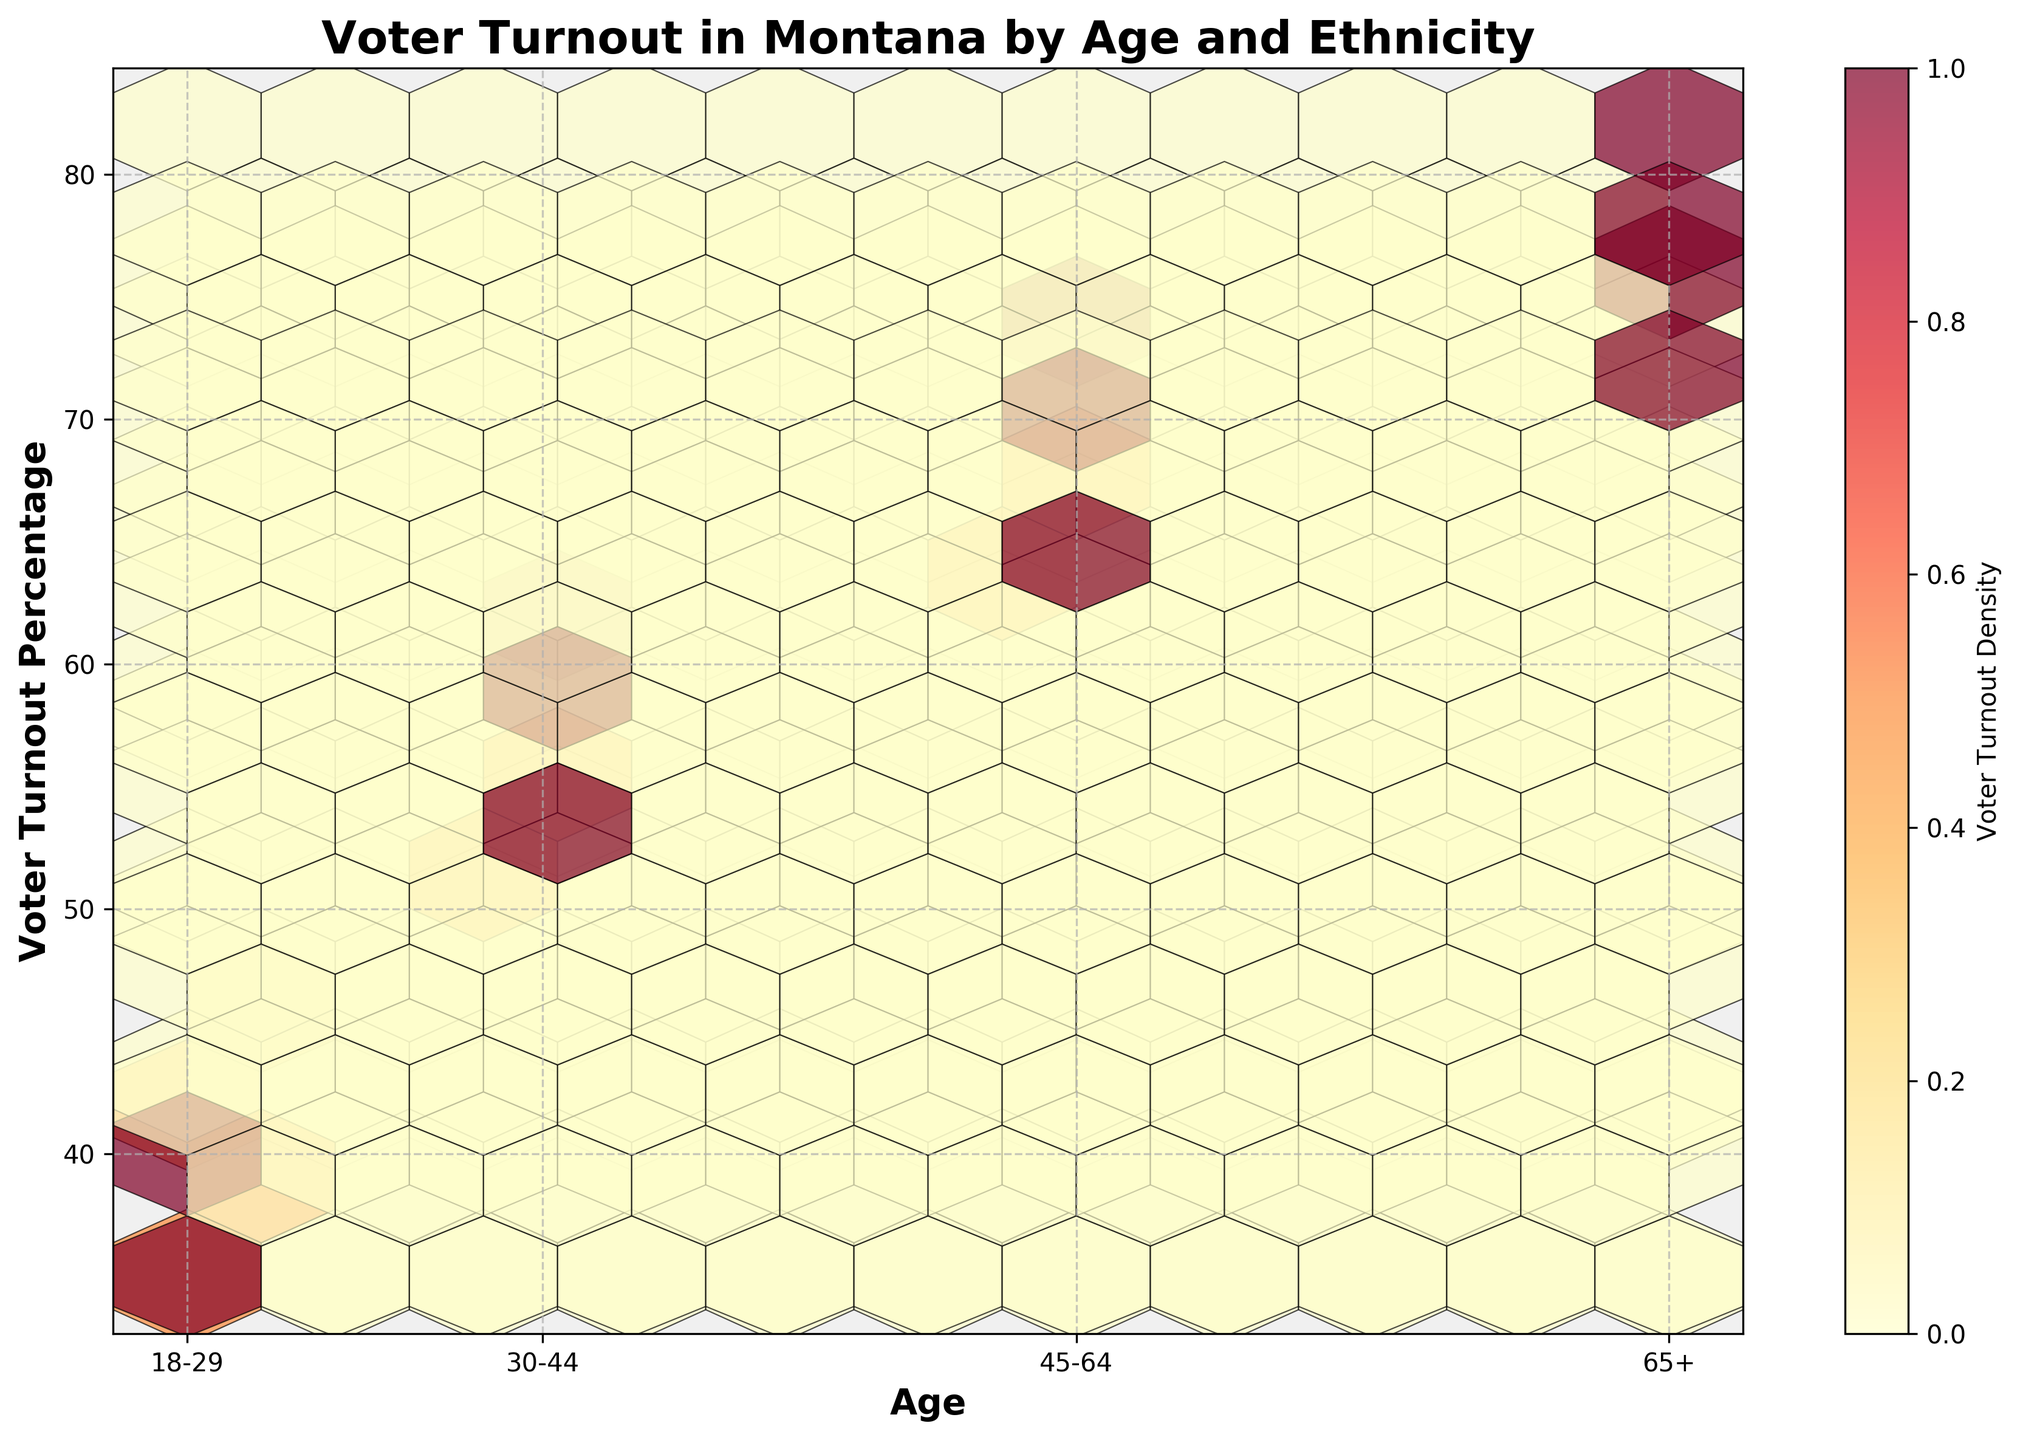what is the title of the figure? The title is written at the top center of the plot in bold font. The title reads 'Voter Turnout in Montana by Age and Ethnicity'.
Answer: Voter Turnout in Montana by Age and Ethnicity what do the x-axis and y-axis represent in the figure? The x-axis represents 'Age' and the y-axis represents 'Voter Turnout Percentage'. This information is displayed in bold font next to both axes.
Answer: Age and Voter Turnout Percentage with which age group does African American voter turnout exceed 70%? By examining the hexbin plot's data points for the African American ethnicity, you can see that the '65+' age group surpasses the 70% voter turnout mark.
Answer: 65+ how does the voter turnout percentage of the 30-44 age group compare between White and Native American ethnicities? The plot shows the voter turnout percentage for the 30-44 age group. For White, it's closer to 60%, and for Native American, it's around 52%. White has a higher turnout.
Answer: White is higher than Native American what is the color scheme used in the hexbin plot? The color scheme used in the hexbin plot is 'YlOrRd'. This range includes yellow, orange, and red hues. The color bar along the side provides the context.
Answer: YlOrRd which ethnicity has the highest voter turnout percentage in the 18-29 age group? To find this, look at the hexbin plot for the 18-29 age range and compare the highlighted points across ethnicities. White ethnicity has the highest voter turnout in this age group at around 45%.
Answer: White compare voter turnout between 2020 and 2016 for the 45-64 age group among African Americans. Look at the clusters for African Americans in the 45-64 age range for both years. The turnout for 2020 is around 68%, while for 2016, it is approximately 65%.
Answer: Higher in 2020 which age group has the highest voter turnout across all ethnicities? Observing the higher clusters of colored hexagons in the plot, the 65+ age group has the highest voter turnout across all ethnicities.
Answer: 65+ describe the density of voter turnout for Native Americans. The density can be inferred from hexagon color intensity and count. Native Americans have lower density clusters (darker colors) and less coverage compared to other ethnicities, indicating lower voter turnout density.
Answer: Lower density what does the color bar indicate in the figure? The color bar on the side of the plot indicates 'Voter Turnout Density.' It shows the concentration levels from low (yellow) to high (red).
Answer: Voter Turnout Density 